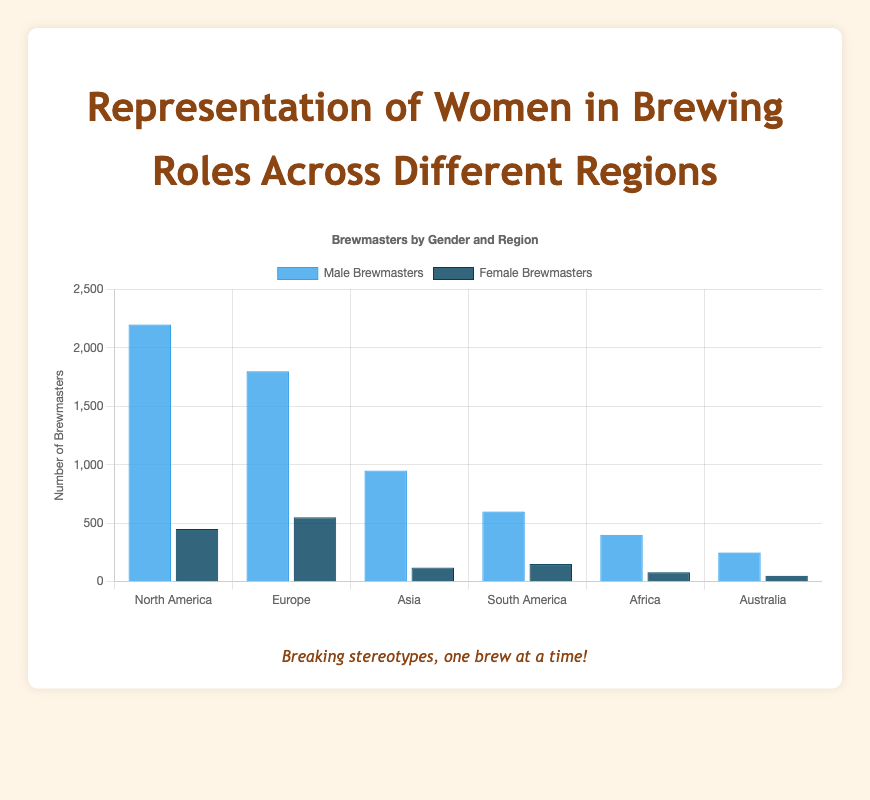Which region has the highest number of male brewmasters? By looking at the figure, the tallest bar in the "Male Brewmasters" category represents the highest number. The bar representing North America is the tallest in this category.
Answer: North America Which region has the highest number of female brewmasters? Looking at the figure, the tallest bar in the "Female Brewmasters" category shows the highest number. The bar representing Europe is the tallest in this category.
Answer: Europe What is the total number of female brewmasters in all regions combined? To find the total, add the height values for all regions in the "Female Brewmasters" category: 450 + 550 + 120 + 150 + 80 + 50 = 1400
Answer: 1400 What is the difference in the number of male and female brewmasters in North America? Subtract the number of female brewmasters from the number of male brewmasters in North America: 2200 - 450 = 1750
Answer: 1750 Which region has the smallest difference in the number of male and female brewmasters? Calculate the difference for each region: North America (2200-450=1750), Europe (1800-550=1250), Asia (950-120=830), South America (600-150=450), Africa (400-80=320), Australia (250-50=200). Australia has the smallest difference.
Answer: Australia What is the approximate ratio of male to female brewmasters in Europe? Divide the number of male brewmasters by the number of female brewmasters in Europe: 1800 / 550 ≈ 3.27
Answer: 3.27 How many more male brewmasters are there than female brewmasters in Asia? Subtract the number of female brewmasters from the number of male brewmasters in Asia: 950 - 120 = 830
Answer: 830 In which region are female brewmasters roughly twice the number of male brewmasters? Looking for a region where the number of female brewmasters is about half the number of male brewmasters. Calculations show that none of the regions meet this condition precisely.
Answer: None What is the combined total number of brewmasters (both male and female) across all regions? Add both categories for all regions: (2200+450) + (1800+550) + (950+120) + (600+150) + (400+80) + (250+50) = 8700
Answer: 8700 Which region has the lowest number of total brewmasters? Calculate the combined number of male and female brewmasters for each region: North America (2200+450=2650), Europe (1800+550=2350), Asia (950+120=1070), South America (600+150=750), Africa (400+80=480), Australia (250+50=300). Australia has the lowest.
Answer: Australia 